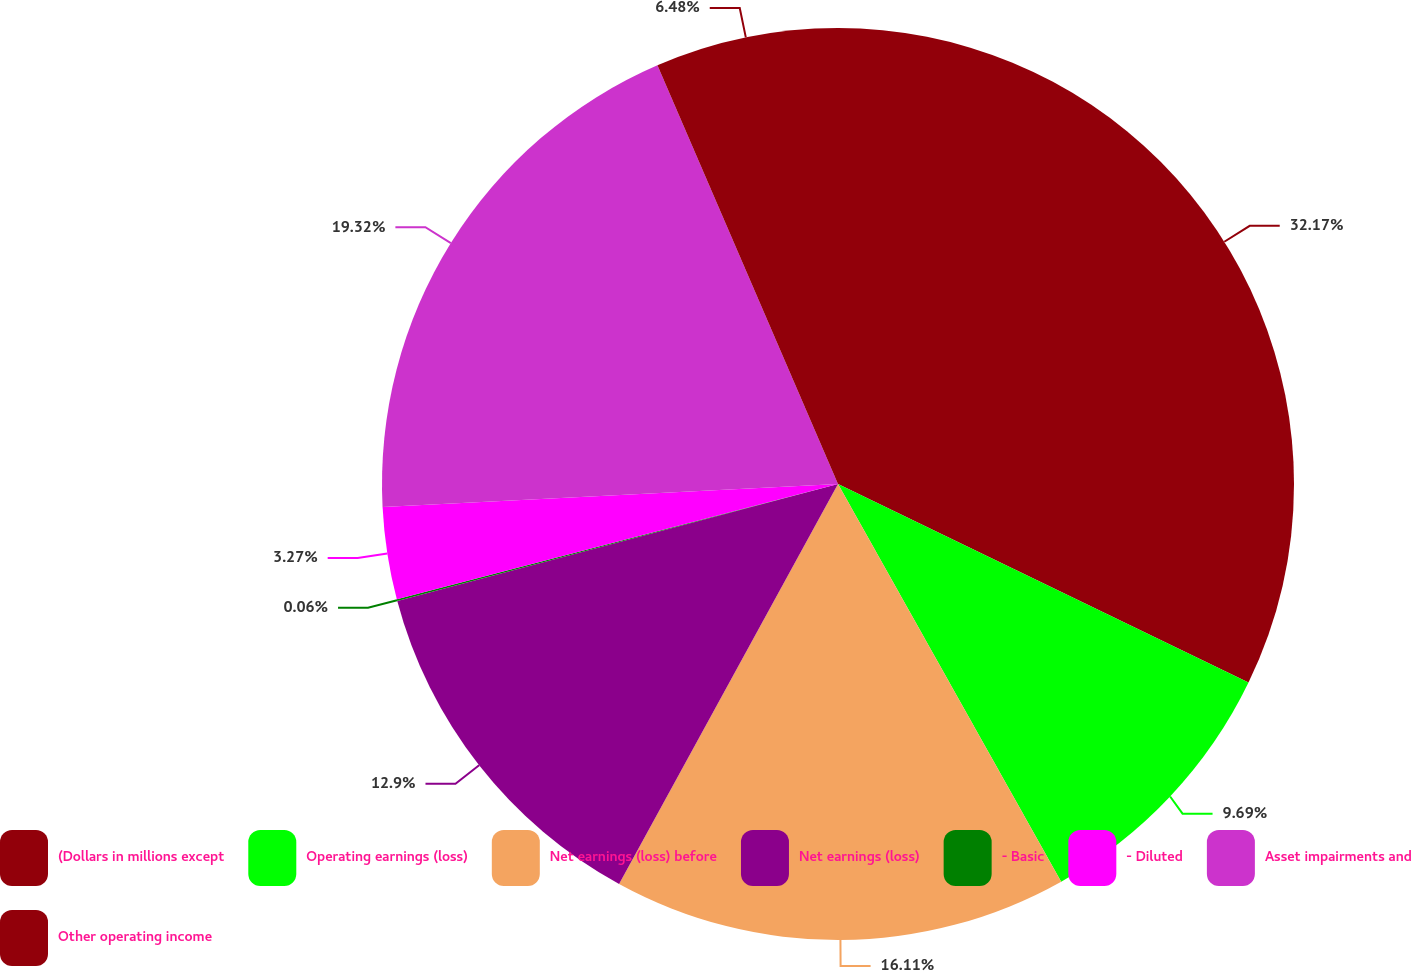Convert chart. <chart><loc_0><loc_0><loc_500><loc_500><pie_chart><fcel>(Dollars in millions except<fcel>Operating earnings (loss)<fcel>Net earnings (loss) before<fcel>Net earnings (loss)<fcel>- Basic<fcel>- Diluted<fcel>Asset impairments and<fcel>Other operating income<nl><fcel>32.17%<fcel>9.69%<fcel>16.11%<fcel>12.9%<fcel>0.06%<fcel>3.27%<fcel>19.32%<fcel>6.48%<nl></chart> 